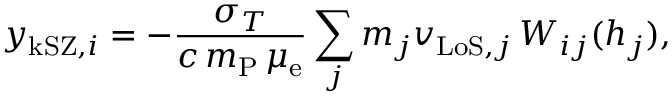Convert formula to latex. <formula><loc_0><loc_0><loc_500><loc_500>y _ { k S Z , i } = - \frac { \sigma _ { T } } { c \, m _ { P } \, \mu _ { e } } \sum _ { j } m _ { j } v _ { L o S , j } \, W _ { i j } ( h _ { j } ) ,</formula> 